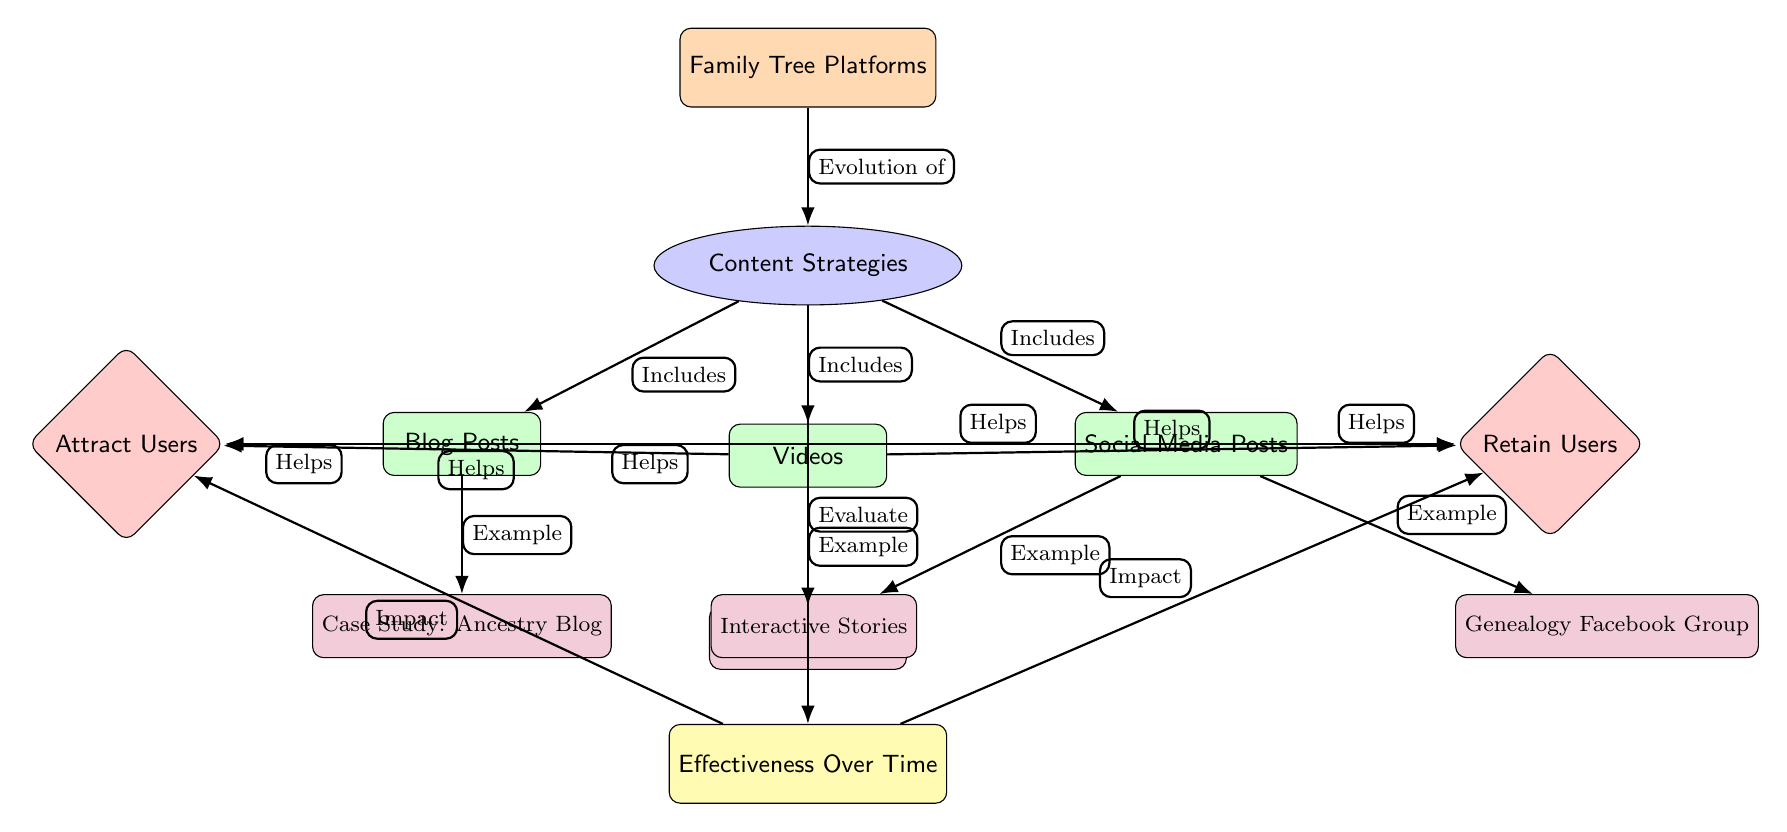What are the three content types included in the strategies? The diagram lists three content strategies: Blog Posts, Videos, and Social Media Posts. These are all represented as content nodes connected to the Content Strategies node.
Answer: Blog Posts, Videos, Social Media Posts What does the 'Content Strategies' node help with? The arrow indicates that Content Strategies helps both to attract and retain users, showing its dual role in user engagement.
Answer: Attract Users, Retain Users Which content type includes "Ancestry Blog"? The node "Ancestry Blog" is connected to the Blog Posts node with an arrow labeled as "Example," indicating that it is an example of the Blog Posts type.
Answer: Blog Posts How many main types of content strategies are in the diagram? There are three main types shown in the diagram (Blog Posts, Videos, Social Media Posts). This is determined by counting the distinct content nodes connected to the Content Strategies node.
Answer: 3 Which content type impacts user retention the most? The diagram does not specify which content type is the most impactful for retention but suggests that all three content types help retain users by having arrows leading from each content type to the Retain Users node.
Answer: Not specified What is the role of the effectiveness node in the diagram? The Effectiveness node is linked to the Content Strategies node and indicates measurement or evaluation of the strategies, impacting both user attraction and retention as shown by the arrows leading from it.
Answer: Evaluate Which two examples come from the Videos content type? The only example listed under the Videos content type is "Tutorial Videos," indicating its relevance as a specific case for this content category. The other example under Social Media is different.
Answer: Tutorial Videos Which node indicates the connecting relationship between platform and content strategies? The arrow labeled "Evolution of" directly connects the Family Tree Platforms node to the Content Strategies node, indicating the relationship that strategies evolve from the platform.
Answer: Evolution of What do all content types help with, according to the diagram? Each content type has arrows pointing to both the Attract Users and Retain Users nodes, indicating that they all aid in attracting and retaining users.
Answer: Attract Users, Retain Users 